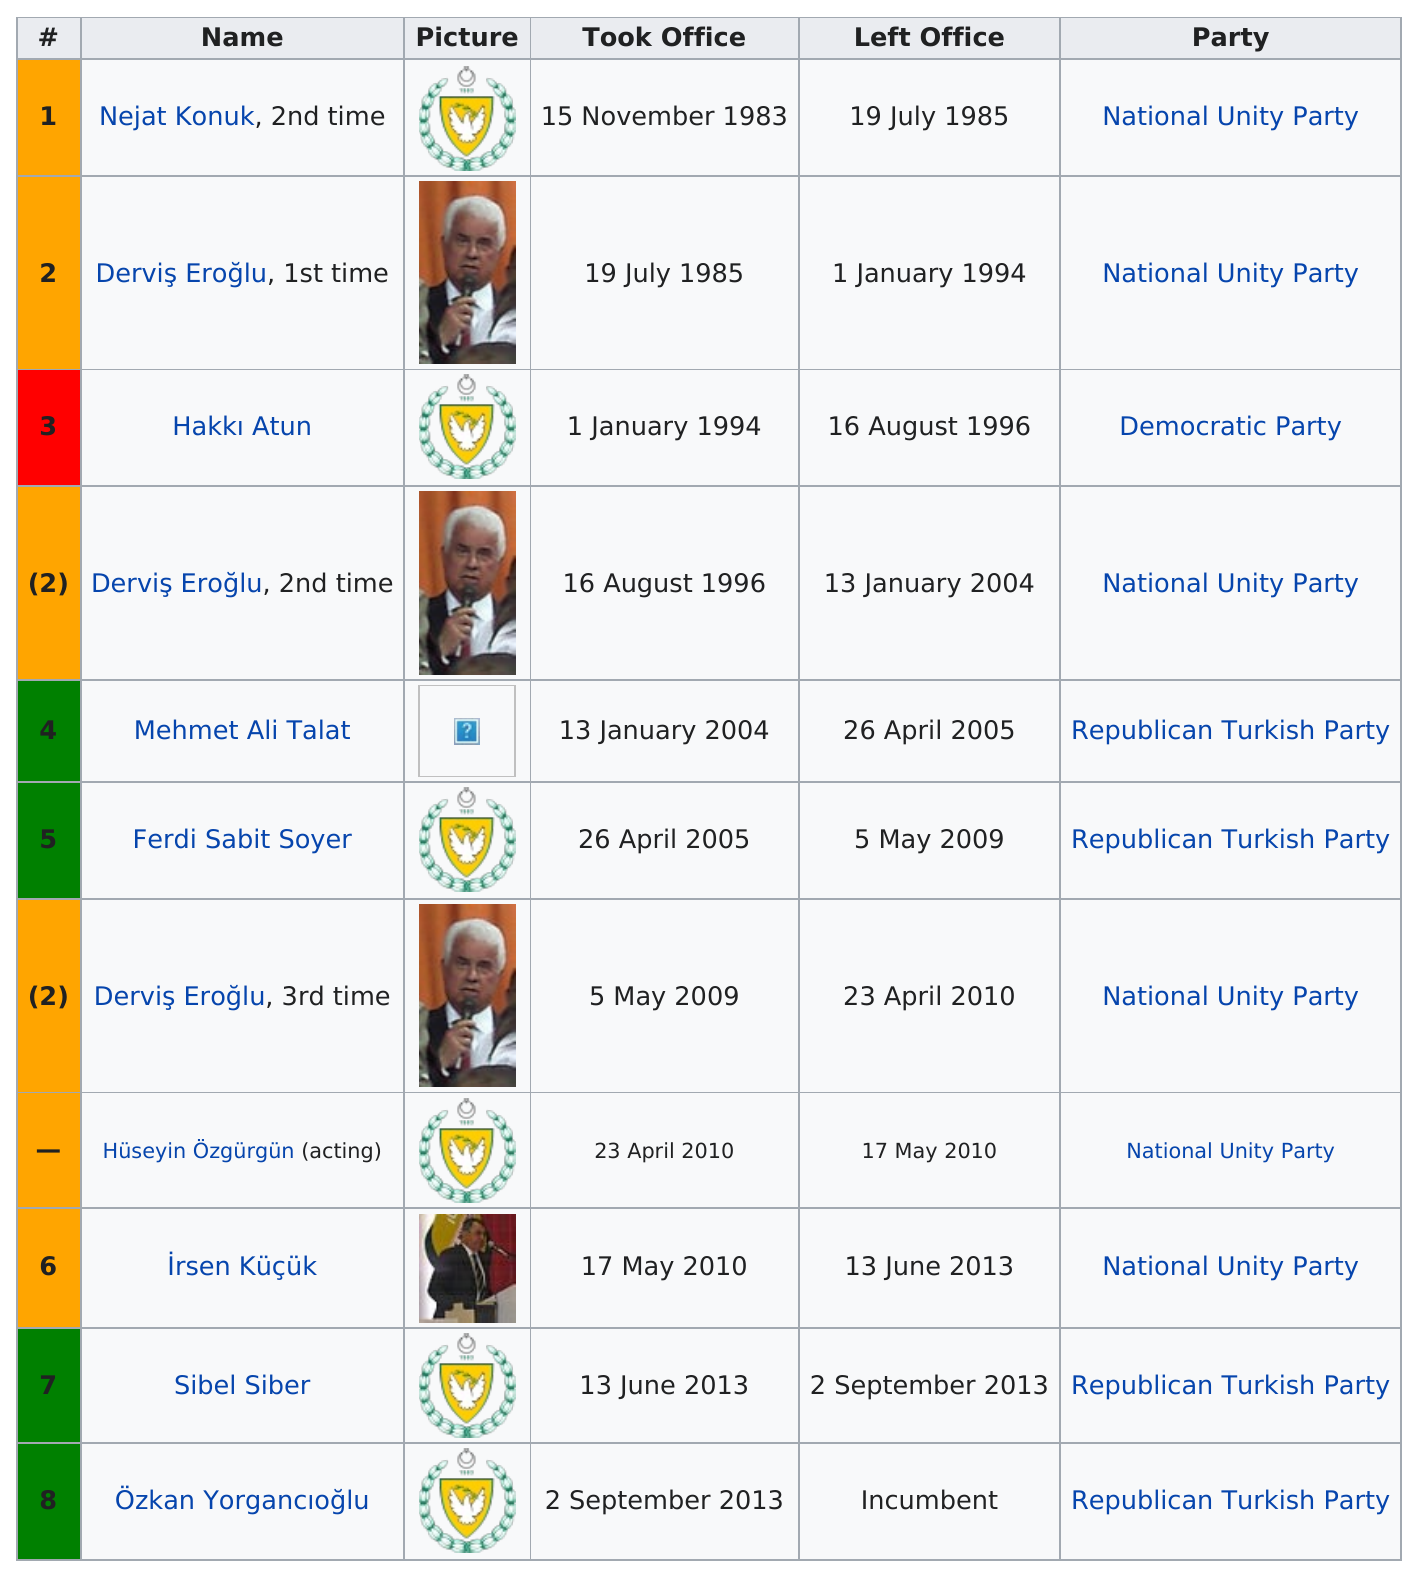Indicate a few pertinent items in this graphic. The National Unity Party has had the most members serve, which highlights its strong and dedicated membership. At least three parties have won. The National Unity Party had the most prime ministers. Derviş Eroğlu has served in office three times. Sibel Siber was the Prime Minister of Turkey after Ferdi Sabit Soyer, who was a member of the Republican Turkish Party. 